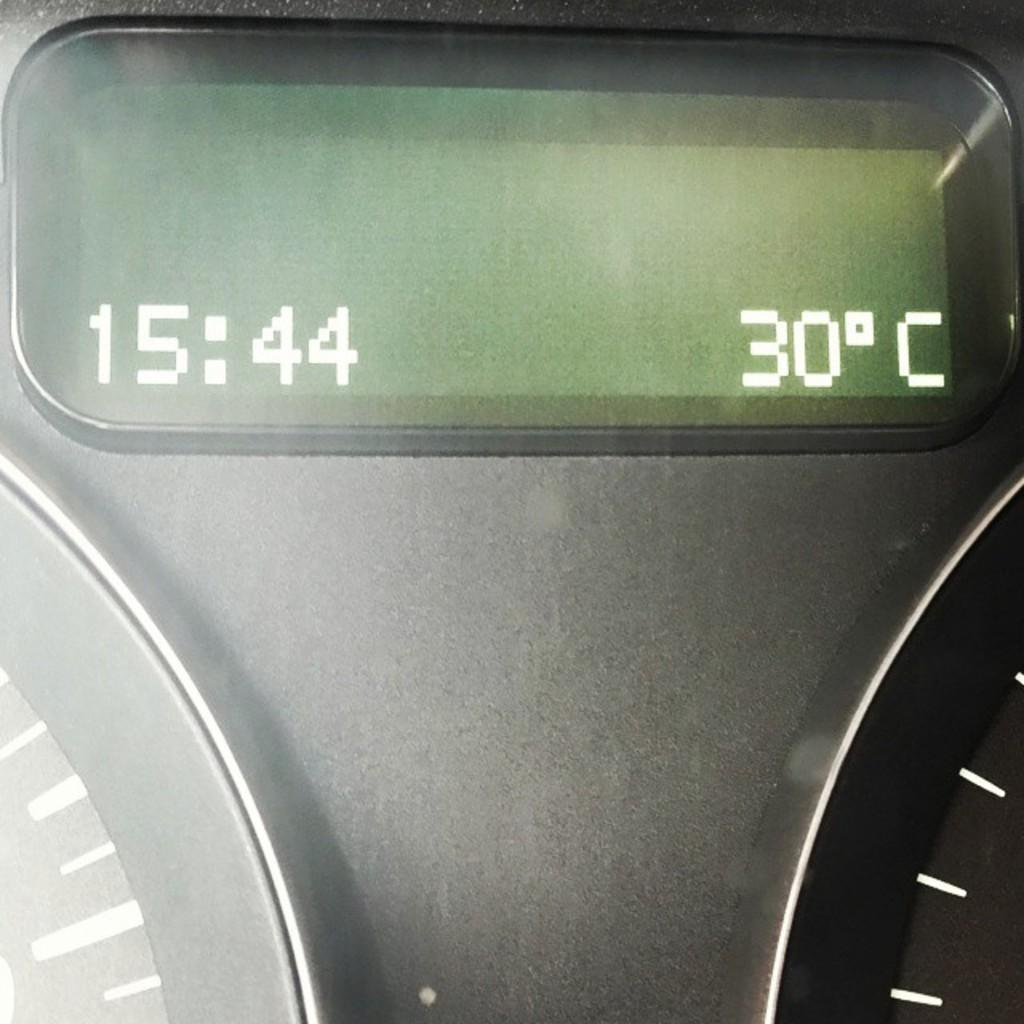<image>
Share a concise interpretation of the image provided. A digital clock displays that it is 15:44 on its left side. 